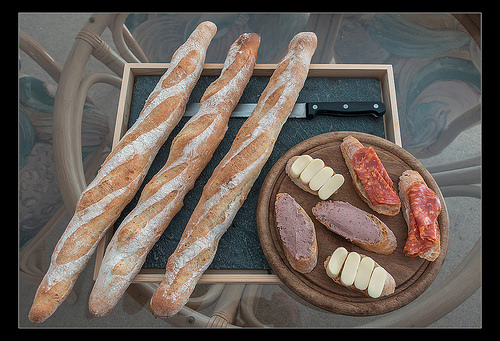<image>
Can you confirm if the baguette is under the knife? No. The baguette is not positioned under the knife. The vertical relationship between these objects is different. 